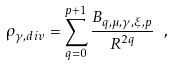<formula> <loc_0><loc_0><loc_500><loc_500>\rho _ { { \gamma } , d i v } = \sum _ { q = 0 } ^ { p + 1 } \frac { B _ { q , \mu , \gamma , \xi , p } } { R ^ { 2 q } } \ ,</formula> 